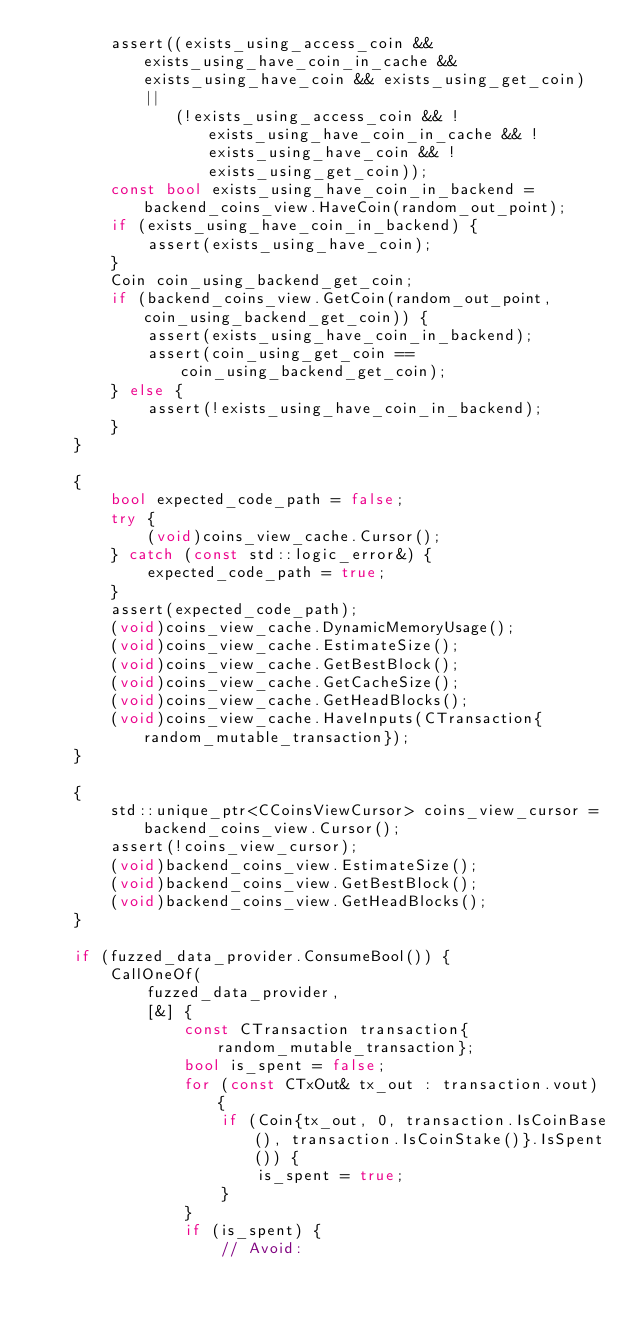<code> <loc_0><loc_0><loc_500><loc_500><_C++_>        assert((exists_using_access_coin && exists_using_have_coin_in_cache && exists_using_have_coin && exists_using_get_coin) ||
               (!exists_using_access_coin && !exists_using_have_coin_in_cache && !exists_using_have_coin && !exists_using_get_coin));
        const bool exists_using_have_coin_in_backend = backend_coins_view.HaveCoin(random_out_point);
        if (exists_using_have_coin_in_backend) {
            assert(exists_using_have_coin);
        }
        Coin coin_using_backend_get_coin;
        if (backend_coins_view.GetCoin(random_out_point, coin_using_backend_get_coin)) {
            assert(exists_using_have_coin_in_backend);
            assert(coin_using_get_coin == coin_using_backend_get_coin);
        } else {
            assert(!exists_using_have_coin_in_backend);
        }
    }

    {
        bool expected_code_path = false;
        try {
            (void)coins_view_cache.Cursor();
        } catch (const std::logic_error&) {
            expected_code_path = true;
        }
        assert(expected_code_path);
        (void)coins_view_cache.DynamicMemoryUsage();
        (void)coins_view_cache.EstimateSize();
        (void)coins_view_cache.GetBestBlock();
        (void)coins_view_cache.GetCacheSize();
        (void)coins_view_cache.GetHeadBlocks();
        (void)coins_view_cache.HaveInputs(CTransaction{random_mutable_transaction});
    }

    {
        std::unique_ptr<CCoinsViewCursor> coins_view_cursor = backend_coins_view.Cursor();
        assert(!coins_view_cursor);
        (void)backend_coins_view.EstimateSize();
        (void)backend_coins_view.GetBestBlock();
        (void)backend_coins_view.GetHeadBlocks();
    }

    if (fuzzed_data_provider.ConsumeBool()) {
        CallOneOf(
            fuzzed_data_provider,
            [&] {
                const CTransaction transaction{random_mutable_transaction};
                bool is_spent = false;
                for (const CTxOut& tx_out : transaction.vout) {
                    if (Coin{tx_out, 0, transaction.IsCoinBase(), transaction.IsCoinStake()}.IsSpent()) {
                        is_spent = true;
                    }
                }
                if (is_spent) {
                    // Avoid:</code> 